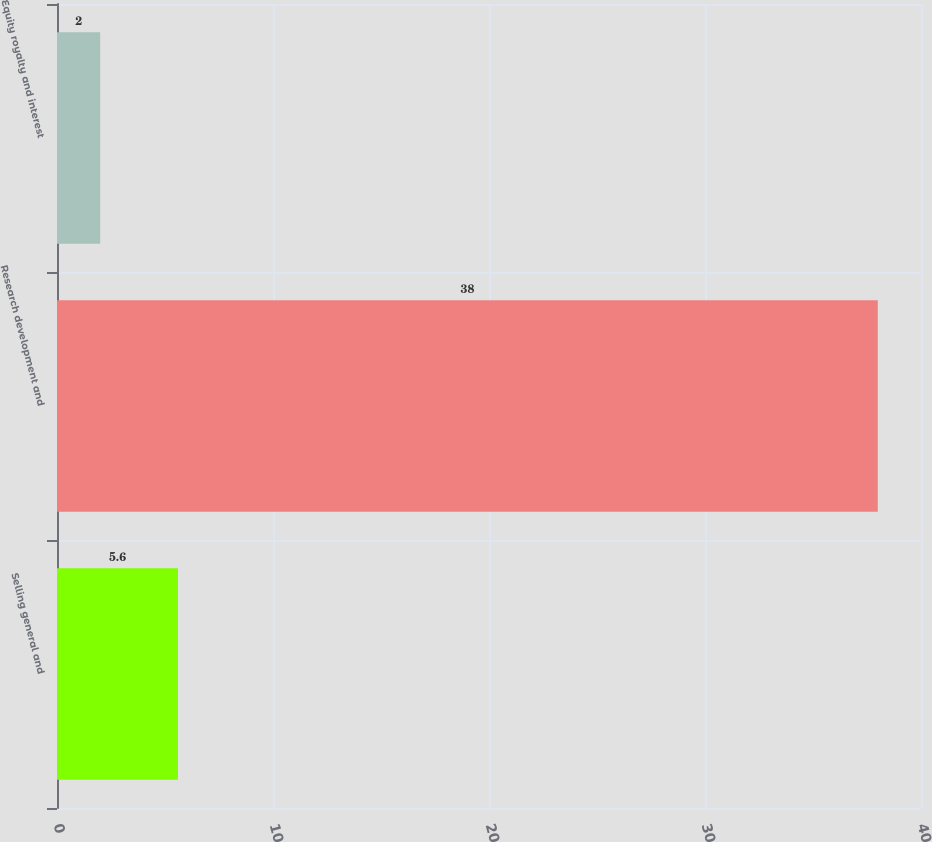Convert chart. <chart><loc_0><loc_0><loc_500><loc_500><bar_chart><fcel>Selling general and<fcel>Research development and<fcel>Equity royalty and interest<nl><fcel>5.6<fcel>38<fcel>2<nl></chart> 